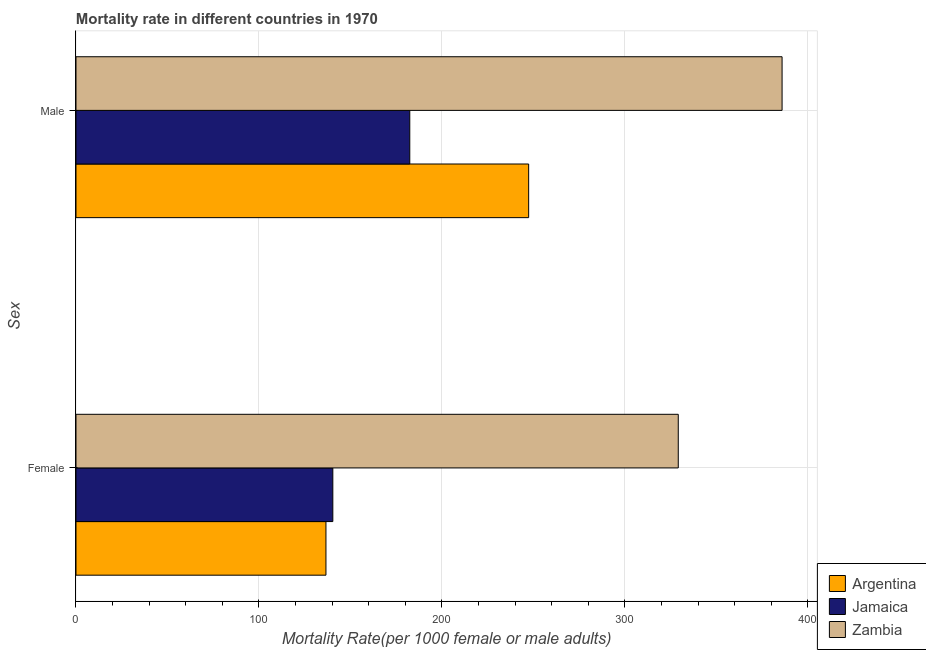How many groups of bars are there?
Ensure brevity in your answer.  2. Are the number of bars per tick equal to the number of legend labels?
Your response must be concise. Yes. What is the label of the 1st group of bars from the top?
Provide a short and direct response. Male. What is the female mortality rate in Jamaica?
Provide a short and direct response. 140.37. Across all countries, what is the maximum male mortality rate?
Provide a short and direct response. 385.91. Across all countries, what is the minimum male mortality rate?
Offer a very short reply. 182.43. In which country was the male mortality rate maximum?
Your answer should be very brief. Zambia. In which country was the female mortality rate minimum?
Provide a short and direct response. Argentina. What is the total female mortality rate in the graph?
Keep it short and to the point. 606.17. What is the difference between the female mortality rate in Argentina and that in Zambia?
Your answer should be compact. -192.56. What is the difference between the female mortality rate in Zambia and the male mortality rate in Argentina?
Offer a terse response. 81.77. What is the average male mortality rate per country?
Provide a succinct answer. 271.92. What is the difference between the female mortality rate and male mortality rate in Zambia?
Your answer should be very brief. -56.74. What is the ratio of the female mortality rate in Jamaica to that in Zambia?
Your answer should be very brief. 0.43. In how many countries, is the male mortality rate greater than the average male mortality rate taken over all countries?
Make the answer very short. 1. What does the 3rd bar from the top in Female represents?
Make the answer very short. Argentina. What does the 3rd bar from the bottom in Male represents?
Offer a terse response. Zambia. How many bars are there?
Provide a short and direct response. 6. Are all the bars in the graph horizontal?
Ensure brevity in your answer.  Yes. How many countries are there in the graph?
Provide a succinct answer. 3. What is the difference between two consecutive major ticks on the X-axis?
Offer a terse response. 100. Where does the legend appear in the graph?
Provide a short and direct response. Bottom right. What is the title of the graph?
Provide a succinct answer. Mortality rate in different countries in 1970. What is the label or title of the X-axis?
Offer a terse response. Mortality Rate(per 1000 female or male adults). What is the label or title of the Y-axis?
Your response must be concise. Sex. What is the Mortality Rate(per 1000 female or male adults) of Argentina in Female?
Keep it short and to the point. 136.62. What is the Mortality Rate(per 1000 female or male adults) of Jamaica in Female?
Your response must be concise. 140.37. What is the Mortality Rate(per 1000 female or male adults) of Zambia in Female?
Provide a short and direct response. 329.18. What is the Mortality Rate(per 1000 female or male adults) in Argentina in Male?
Your answer should be compact. 247.41. What is the Mortality Rate(per 1000 female or male adults) of Jamaica in Male?
Your answer should be very brief. 182.43. What is the Mortality Rate(per 1000 female or male adults) in Zambia in Male?
Keep it short and to the point. 385.91. Across all Sex, what is the maximum Mortality Rate(per 1000 female or male adults) of Argentina?
Provide a succinct answer. 247.41. Across all Sex, what is the maximum Mortality Rate(per 1000 female or male adults) of Jamaica?
Provide a succinct answer. 182.43. Across all Sex, what is the maximum Mortality Rate(per 1000 female or male adults) of Zambia?
Offer a very short reply. 385.91. Across all Sex, what is the minimum Mortality Rate(per 1000 female or male adults) of Argentina?
Make the answer very short. 136.62. Across all Sex, what is the minimum Mortality Rate(per 1000 female or male adults) in Jamaica?
Provide a succinct answer. 140.37. Across all Sex, what is the minimum Mortality Rate(per 1000 female or male adults) of Zambia?
Offer a terse response. 329.18. What is the total Mortality Rate(per 1000 female or male adults) of Argentina in the graph?
Ensure brevity in your answer.  384.03. What is the total Mortality Rate(per 1000 female or male adults) in Jamaica in the graph?
Keep it short and to the point. 322.81. What is the total Mortality Rate(per 1000 female or male adults) in Zambia in the graph?
Make the answer very short. 715.09. What is the difference between the Mortality Rate(per 1000 female or male adults) in Argentina in Female and that in Male?
Provide a short and direct response. -110.79. What is the difference between the Mortality Rate(per 1000 female or male adults) in Jamaica in Female and that in Male?
Offer a terse response. -42.06. What is the difference between the Mortality Rate(per 1000 female or male adults) of Zambia in Female and that in Male?
Your response must be concise. -56.74. What is the difference between the Mortality Rate(per 1000 female or male adults) of Argentina in Female and the Mortality Rate(per 1000 female or male adults) of Jamaica in Male?
Give a very brief answer. -45.82. What is the difference between the Mortality Rate(per 1000 female or male adults) of Argentina in Female and the Mortality Rate(per 1000 female or male adults) of Zambia in Male?
Offer a very short reply. -249.3. What is the difference between the Mortality Rate(per 1000 female or male adults) of Jamaica in Female and the Mortality Rate(per 1000 female or male adults) of Zambia in Male?
Your answer should be very brief. -245.54. What is the average Mortality Rate(per 1000 female or male adults) in Argentina per Sex?
Provide a succinct answer. 192.01. What is the average Mortality Rate(per 1000 female or male adults) in Jamaica per Sex?
Ensure brevity in your answer.  161.4. What is the average Mortality Rate(per 1000 female or male adults) of Zambia per Sex?
Give a very brief answer. 357.54. What is the difference between the Mortality Rate(per 1000 female or male adults) of Argentina and Mortality Rate(per 1000 female or male adults) of Jamaica in Female?
Your answer should be very brief. -3.76. What is the difference between the Mortality Rate(per 1000 female or male adults) in Argentina and Mortality Rate(per 1000 female or male adults) in Zambia in Female?
Make the answer very short. -192.56. What is the difference between the Mortality Rate(per 1000 female or male adults) in Jamaica and Mortality Rate(per 1000 female or male adults) in Zambia in Female?
Provide a succinct answer. -188.8. What is the difference between the Mortality Rate(per 1000 female or male adults) of Argentina and Mortality Rate(per 1000 female or male adults) of Jamaica in Male?
Your answer should be compact. 64.97. What is the difference between the Mortality Rate(per 1000 female or male adults) in Argentina and Mortality Rate(per 1000 female or male adults) in Zambia in Male?
Keep it short and to the point. -138.5. What is the difference between the Mortality Rate(per 1000 female or male adults) in Jamaica and Mortality Rate(per 1000 female or male adults) in Zambia in Male?
Provide a succinct answer. -203.48. What is the ratio of the Mortality Rate(per 1000 female or male adults) in Argentina in Female to that in Male?
Make the answer very short. 0.55. What is the ratio of the Mortality Rate(per 1000 female or male adults) in Jamaica in Female to that in Male?
Offer a very short reply. 0.77. What is the ratio of the Mortality Rate(per 1000 female or male adults) of Zambia in Female to that in Male?
Make the answer very short. 0.85. What is the difference between the highest and the second highest Mortality Rate(per 1000 female or male adults) in Argentina?
Provide a succinct answer. 110.79. What is the difference between the highest and the second highest Mortality Rate(per 1000 female or male adults) in Jamaica?
Give a very brief answer. 42.06. What is the difference between the highest and the second highest Mortality Rate(per 1000 female or male adults) in Zambia?
Ensure brevity in your answer.  56.74. What is the difference between the highest and the lowest Mortality Rate(per 1000 female or male adults) in Argentina?
Make the answer very short. 110.79. What is the difference between the highest and the lowest Mortality Rate(per 1000 female or male adults) of Jamaica?
Give a very brief answer. 42.06. What is the difference between the highest and the lowest Mortality Rate(per 1000 female or male adults) in Zambia?
Offer a terse response. 56.74. 